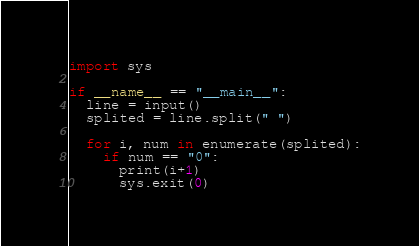Convert code to text. <code><loc_0><loc_0><loc_500><loc_500><_Python_>import sys

if __name__ == "__main__":
  line = input()
  splited = line.split(" ")
  
  for i, num in enumerate(splited):
    if num == "0":
      print(i+1)
      sys.exit(0)</code> 